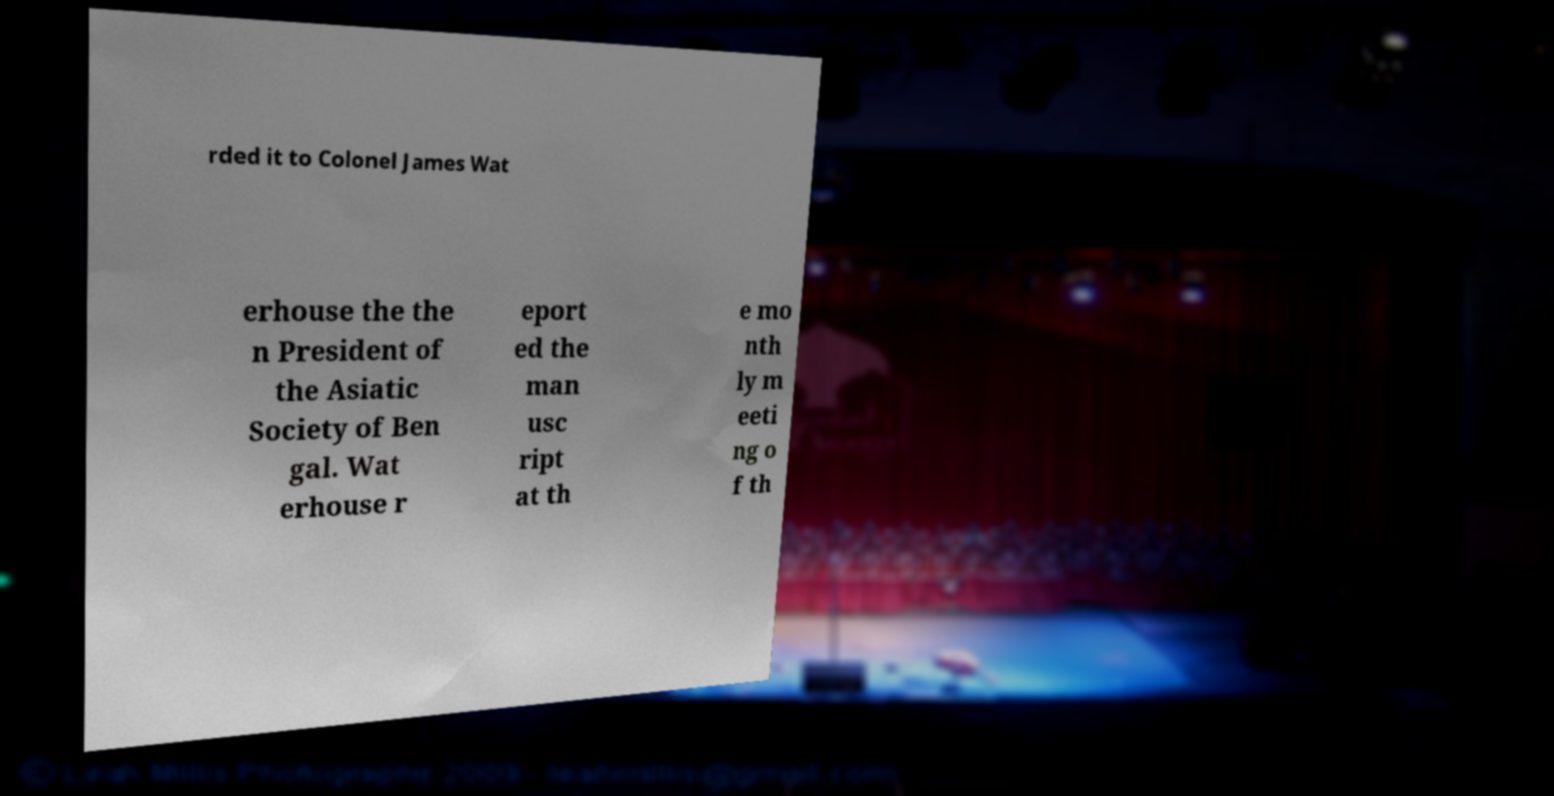Can you accurately transcribe the text from the provided image for me? rded it to Colonel James Wat erhouse the the n President of the Asiatic Society of Ben gal. Wat erhouse r eport ed the man usc ript at th e mo nth ly m eeti ng o f th 